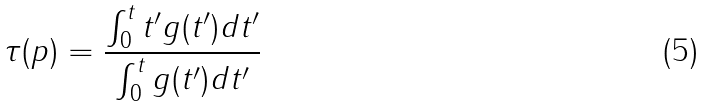Convert formula to latex. <formula><loc_0><loc_0><loc_500><loc_500>\tau ( p ) = \frac { \int _ { 0 } ^ { t } t ^ { \prime } g ( t ^ { \prime } ) d t ^ { \prime } } { \int _ { 0 } ^ { t } g ( t ^ { \prime } ) d t ^ { \prime } }</formula> 